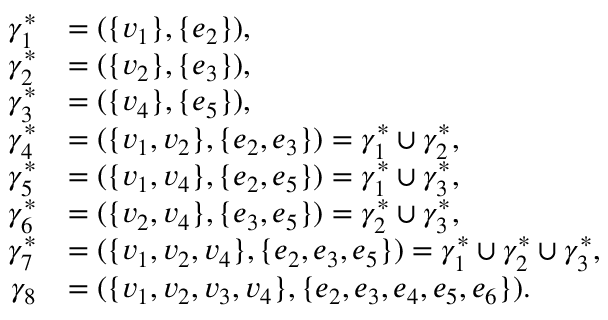<formula> <loc_0><loc_0><loc_500><loc_500>\begin{array} { r l } { \gamma _ { 1 } ^ { \ast } } & { = ( \{ v _ { 1 } \} , \{ e _ { 2 } \} ) , } \\ { \gamma _ { 2 } ^ { \ast } } & { = ( \{ v _ { 2 } \} , \{ e _ { 3 } \} ) , } \\ { \gamma _ { 3 } ^ { \ast } } & { = ( \{ v _ { 4 } \} , \{ e _ { 5 } \} ) , } \\ { \gamma _ { 4 } ^ { \ast } } & { = ( \{ v _ { 1 } , v _ { 2 } \} , \{ e _ { 2 } , e _ { 3 } \} ) = \gamma _ { 1 } ^ { \ast } \cup \gamma _ { 2 } ^ { \ast } , } \\ { \gamma _ { 5 } ^ { \ast } } & { = ( \{ v _ { 1 } , v _ { 4 } \} , \{ e _ { 2 } , e _ { 5 } \} ) = \gamma _ { 1 } ^ { \ast } \cup \gamma _ { 3 } ^ { \ast } , } \\ { \gamma _ { 6 } ^ { \ast } } & { = ( \{ v _ { 2 } , v _ { 4 } \} , \{ e _ { 3 } , e _ { 5 } \} ) = \gamma _ { 2 } ^ { \ast } \cup \gamma _ { 3 } ^ { \ast } , } \\ { \gamma _ { 7 } ^ { \ast } } & { = ( \{ v _ { 1 } , v _ { 2 } , v _ { 4 } \} , \{ e _ { 2 } , e _ { 3 } , e _ { 5 } \} ) = \gamma _ { 1 } ^ { \ast } \cup \gamma _ { 2 } ^ { \ast } \cup \gamma _ { 3 } ^ { \ast } , } \\ { \gamma _ { 8 } } & { = ( \{ v _ { 1 } , v _ { 2 } , v _ { 3 } , v _ { 4 } \} , \{ e _ { 2 } , e _ { 3 } , e _ { 4 } , e _ { 5 } , e _ { 6 } \} ) . } \end{array}</formula> 